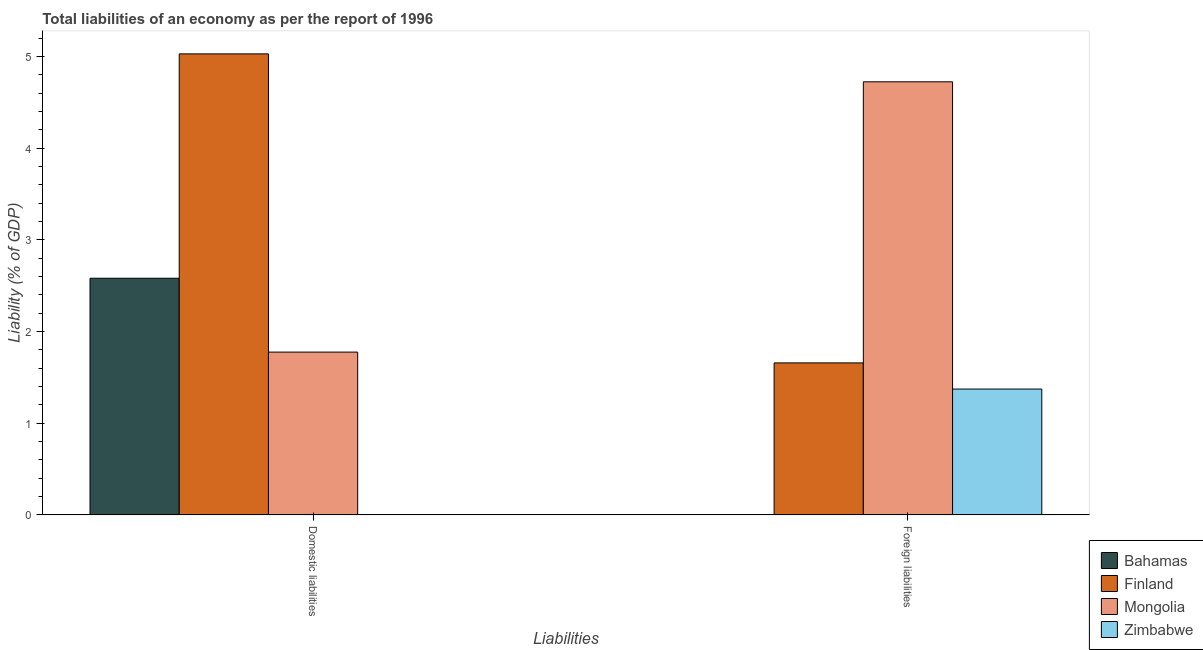How many groups of bars are there?
Provide a succinct answer. 2. What is the label of the 2nd group of bars from the left?
Offer a terse response. Foreign liabilities. What is the incurrence of foreign liabilities in Zimbabwe?
Make the answer very short. 1.37. Across all countries, what is the maximum incurrence of domestic liabilities?
Your answer should be compact. 5.03. In which country was the incurrence of domestic liabilities maximum?
Offer a very short reply. Finland. What is the total incurrence of domestic liabilities in the graph?
Provide a succinct answer. 9.39. What is the difference between the incurrence of foreign liabilities in Mongolia and that in Zimbabwe?
Ensure brevity in your answer.  3.35. What is the difference between the incurrence of domestic liabilities in Finland and the incurrence of foreign liabilities in Zimbabwe?
Your response must be concise. 3.66. What is the average incurrence of domestic liabilities per country?
Your response must be concise. 2.35. What is the difference between the incurrence of foreign liabilities and incurrence of domestic liabilities in Mongolia?
Offer a terse response. 2.95. In how many countries, is the incurrence of domestic liabilities greater than 2.4 %?
Keep it short and to the point. 2. What is the ratio of the incurrence of foreign liabilities in Zimbabwe to that in Finland?
Your response must be concise. 0.83. In how many countries, is the incurrence of foreign liabilities greater than the average incurrence of foreign liabilities taken over all countries?
Your answer should be compact. 1. How many bars are there?
Provide a succinct answer. 6. Are all the bars in the graph horizontal?
Provide a succinct answer. No. Where does the legend appear in the graph?
Your answer should be very brief. Bottom right. How are the legend labels stacked?
Keep it short and to the point. Vertical. What is the title of the graph?
Your answer should be compact. Total liabilities of an economy as per the report of 1996. Does "Equatorial Guinea" appear as one of the legend labels in the graph?
Your response must be concise. No. What is the label or title of the X-axis?
Provide a short and direct response. Liabilities. What is the label or title of the Y-axis?
Your answer should be very brief. Liability (% of GDP). What is the Liability (% of GDP) in Bahamas in Domestic liabilities?
Give a very brief answer. 2.58. What is the Liability (% of GDP) in Finland in Domestic liabilities?
Provide a succinct answer. 5.03. What is the Liability (% of GDP) in Mongolia in Domestic liabilities?
Keep it short and to the point. 1.78. What is the Liability (% of GDP) in Zimbabwe in Domestic liabilities?
Your answer should be compact. 0. What is the Liability (% of GDP) in Bahamas in Foreign liabilities?
Ensure brevity in your answer.  0. What is the Liability (% of GDP) in Finland in Foreign liabilities?
Your answer should be very brief. 1.66. What is the Liability (% of GDP) in Mongolia in Foreign liabilities?
Your answer should be very brief. 4.73. What is the Liability (% of GDP) in Zimbabwe in Foreign liabilities?
Keep it short and to the point. 1.37. Across all Liabilities, what is the maximum Liability (% of GDP) in Bahamas?
Offer a very short reply. 2.58. Across all Liabilities, what is the maximum Liability (% of GDP) in Finland?
Your answer should be very brief. 5.03. Across all Liabilities, what is the maximum Liability (% of GDP) of Mongolia?
Provide a short and direct response. 4.73. Across all Liabilities, what is the maximum Liability (% of GDP) in Zimbabwe?
Your answer should be very brief. 1.37. Across all Liabilities, what is the minimum Liability (% of GDP) of Finland?
Ensure brevity in your answer.  1.66. Across all Liabilities, what is the minimum Liability (% of GDP) in Mongolia?
Give a very brief answer. 1.78. What is the total Liability (% of GDP) of Bahamas in the graph?
Provide a succinct answer. 2.58. What is the total Liability (% of GDP) of Finland in the graph?
Provide a short and direct response. 6.69. What is the total Liability (% of GDP) of Mongolia in the graph?
Your answer should be very brief. 6.5. What is the total Liability (% of GDP) of Zimbabwe in the graph?
Provide a short and direct response. 1.37. What is the difference between the Liability (% of GDP) in Finland in Domestic liabilities and that in Foreign liabilities?
Your answer should be very brief. 3.37. What is the difference between the Liability (% of GDP) of Mongolia in Domestic liabilities and that in Foreign liabilities?
Your answer should be very brief. -2.95. What is the difference between the Liability (% of GDP) of Bahamas in Domestic liabilities and the Liability (% of GDP) of Finland in Foreign liabilities?
Offer a terse response. 0.92. What is the difference between the Liability (% of GDP) in Bahamas in Domestic liabilities and the Liability (% of GDP) in Mongolia in Foreign liabilities?
Keep it short and to the point. -2.14. What is the difference between the Liability (% of GDP) of Bahamas in Domestic liabilities and the Liability (% of GDP) of Zimbabwe in Foreign liabilities?
Your response must be concise. 1.21. What is the difference between the Liability (% of GDP) of Finland in Domestic liabilities and the Liability (% of GDP) of Mongolia in Foreign liabilities?
Provide a short and direct response. 0.3. What is the difference between the Liability (% of GDP) in Finland in Domestic liabilities and the Liability (% of GDP) in Zimbabwe in Foreign liabilities?
Keep it short and to the point. 3.66. What is the difference between the Liability (% of GDP) of Mongolia in Domestic liabilities and the Liability (% of GDP) of Zimbabwe in Foreign liabilities?
Offer a very short reply. 0.4. What is the average Liability (% of GDP) of Bahamas per Liabilities?
Provide a short and direct response. 1.29. What is the average Liability (% of GDP) of Finland per Liabilities?
Keep it short and to the point. 3.34. What is the average Liability (% of GDP) in Mongolia per Liabilities?
Make the answer very short. 3.25. What is the average Liability (% of GDP) of Zimbabwe per Liabilities?
Offer a very short reply. 0.69. What is the difference between the Liability (% of GDP) in Bahamas and Liability (% of GDP) in Finland in Domestic liabilities?
Provide a short and direct response. -2.45. What is the difference between the Liability (% of GDP) of Bahamas and Liability (% of GDP) of Mongolia in Domestic liabilities?
Keep it short and to the point. 0.81. What is the difference between the Liability (% of GDP) in Finland and Liability (% of GDP) in Mongolia in Domestic liabilities?
Offer a terse response. 3.25. What is the difference between the Liability (% of GDP) in Finland and Liability (% of GDP) in Mongolia in Foreign liabilities?
Make the answer very short. -3.07. What is the difference between the Liability (% of GDP) of Finland and Liability (% of GDP) of Zimbabwe in Foreign liabilities?
Offer a very short reply. 0.29. What is the difference between the Liability (% of GDP) of Mongolia and Liability (% of GDP) of Zimbabwe in Foreign liabilities?
Keep it short and to the point. 3.35. What is the ratio of the Liability (% of GDP) of Finland in Domestic liabilities to that in Foreign liabilities?
Make the answer very short. 3.03. What is the ratio of the Liability (% of GDP) in Mongolia in Domestic liabilities to that in Foreign liabilities?
Offer a very short reply. 0.38. What is the difference between the highest and the second highest Liability (% of GDP) in Finland?
Offer a very short reply. 3.37. What is the difference between the highest and the second highest Liability (% of GDP) of Mongolia?
Ensure brevity in your answer.  2.95. What is the difference between the highest and the lowest Liability (% of GDP) in Bahamas?
Provide a succinct answer. 2.58. What is the difference between the highest and the lowest Liability (% of GDP) in Finland?
Make the answer very short. 3.37. What is the difference between the highest and the lowest Liability (% of GDP) in Mongolia?
Ensure brevity in your answer.  2.95. What is the difference between the highest and the lowest Liability (% of GDP) in Zimbabwe?
Keep it short and to the point. 1.37. 